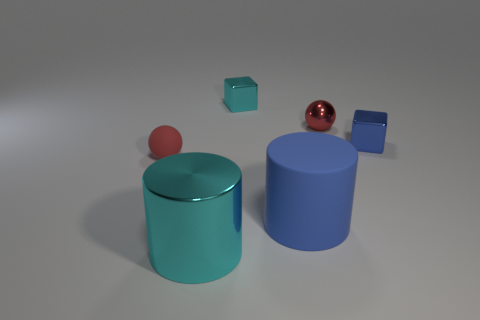There is another small thing that is the same color as the tiny matte object; what is its material?
Offer a very short reply. Metal. What material is the other large blue object that is the same shape as the big metal object?
Provide a succinct answer. Rubber. How many gray matte things have the same shape as the blue metal thing?
Offer a terse response. 0. There is a big thing to the right of the tiny cube that is left of the big cylinder that is to the right of the cyan cube; what is its shape?
Offer a very short reply. Cylinder. What is the material of the tiny thing that is left of the small blue metallic thing and to the right of the cyan metal block?
Make the answer very short. Metal. There is a ball on the left side of the metal cylinder; is its size the same as the blue shiny cube?
Your response must be concise. Yes. Is there anything else that is the same size as the metallic cylinder?
Offer a terse response. Yes. Is the number of red rubber objects that are on the right side of the big cyan cylinder greater than the number of tiny matte balls in front of the tiny metal sphere?
Keep it short and to the point. No. What color is the metallic object that is in front of the small object left of the block behind the blue cube?
Provide a short and direct response. Cyan. There is a shiny block right of the big blue thing; is its color the same as the rubber sphere?
Provide a succinct answer. No. 